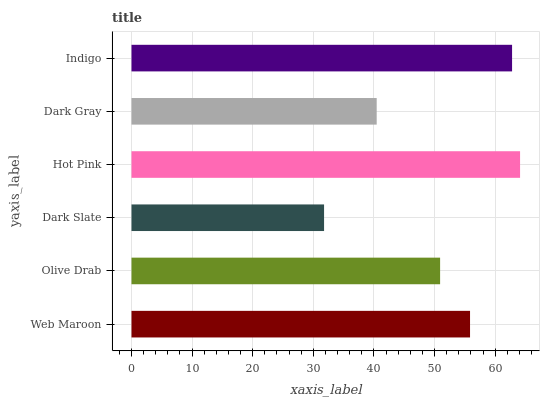Is Dark Slate the minimum?
Answer yes or no. Yes. Is Hot Pink the maximum?
Answer yes or no. Yes. Is Olive Drab the minimum?
Answer yes or no. No. Is Olive Drab the maximum?
Answer yes or no. No. Is Web Maroon greater than Olive Drab?
Answer yes or no. Yes. Is Olive Drab less than Web Maroon?
Answer yes or no. Yes. Is Olive Drab greater than Web Maroon?
Answer yes or no. No. Is Web Maroon less than Olive Drab?
Answer yes or no. No. Is Web Maroon the high median?
Answer yes or no. Yes. Is Olive Drab the low median?
Answer yes or no. Yes. Is Olive Drab the high median?
Answer yes or no. No. Is Dark Gray the low median?
Answer yes or no. No. 